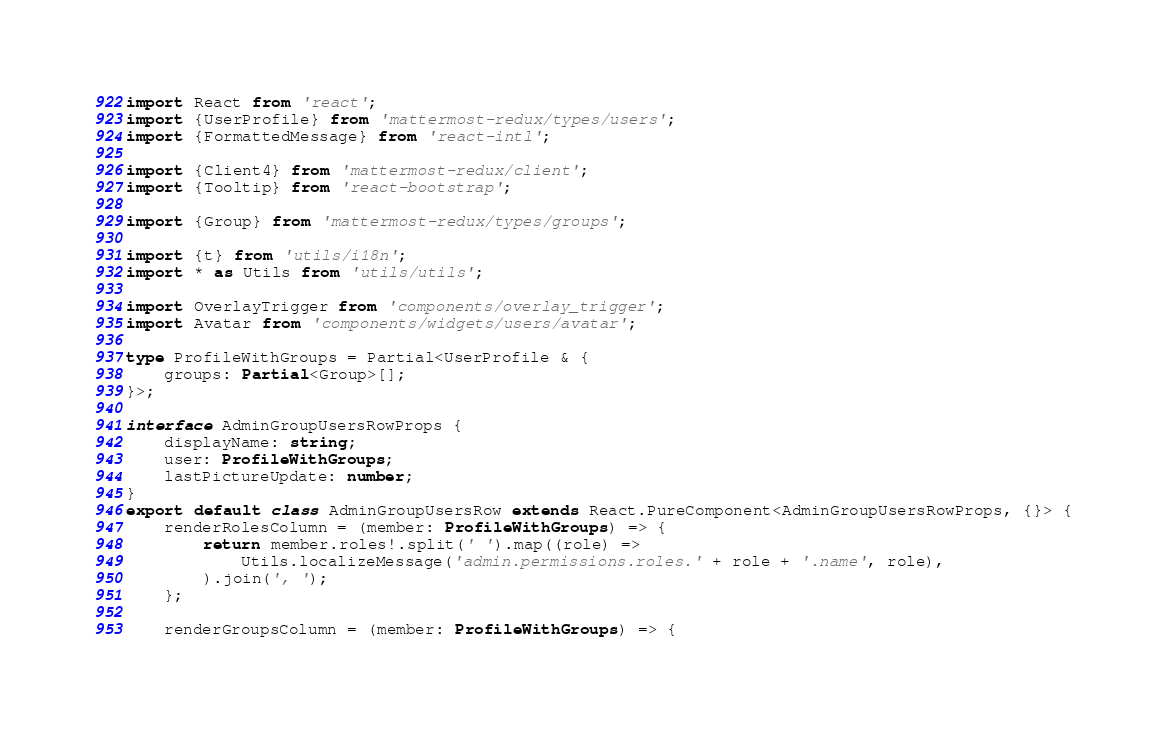Convert code to text. <code><loc_0><loc_0><loc_500><loc_500><_TypeScript_>import React from 'react';
import {UserProfile} from 'mattermost-redux/types/users';
import {FormattedMessage} from 'react-intl';

import {Client4} from 'mattermost-redux/client';
import {Tooltip} from 'react-bootstrap';

import {Group} from 'mattermost-redux/types/groups';

import {t} from 'utils/i18n';
import * as Utils from 'utils/utils';

import OverlayTrigger from 'components/overlay_trigger';
import Avatar from 'components/widgets/users/avatar';

type ProfileWithGroups = Partial<UserProfile & {
    groups: Partial<Group>[];
}>;

interface AdminGroupUsersRowProps {
    displayName: string;
    user: ProfileWithGroups;
    lastPictureUpdate: number;
}
export default class AdminGroupUsersRow extends React.PureComponent<AdminGroupUsersRowProps, {}> {
    renderRolesColumn = (member: ProfileWithGroups) => {
        return member.roles!.split(' ').map((role) =>
            Utils.localizeMessage('admin.permissions.roles.' + role + '.name', role),
        ).join(', ');
    };

    renderGroupsColumn = (member: ProfileWithGroups) => {</code> 